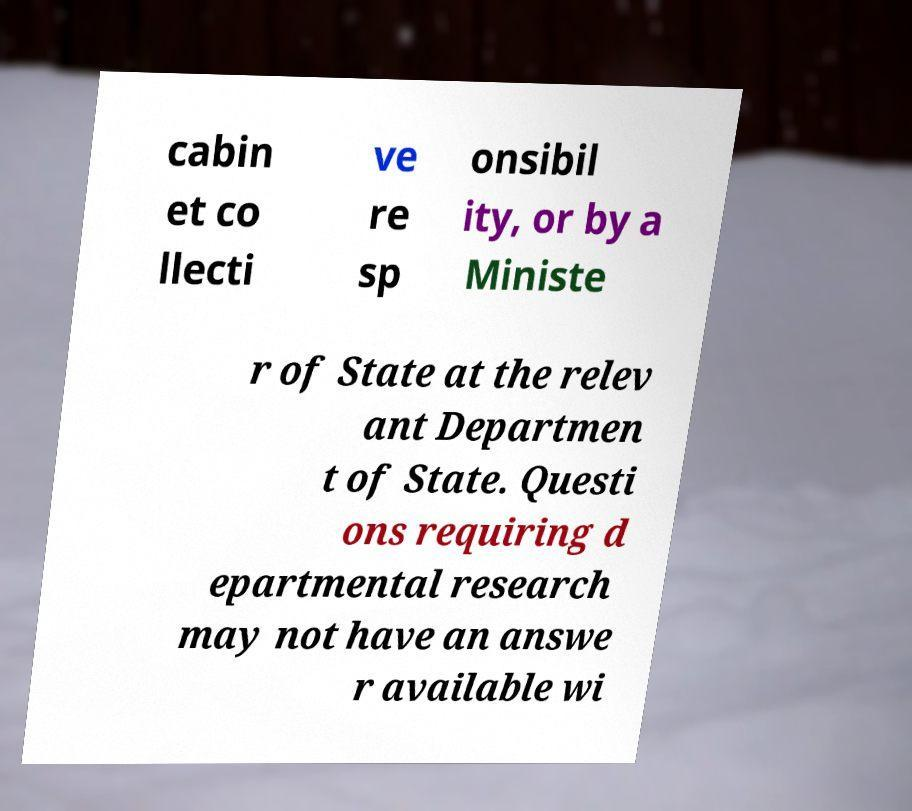What messages or text are displayed in this image? I need them in a readable, typed format. cabin et co llecti ve re sp onsibil ity, or by a Ministe r of State at the relev ant Departmen t of State. Questi ons requiring d epartmental research may not have an answe r available wi 